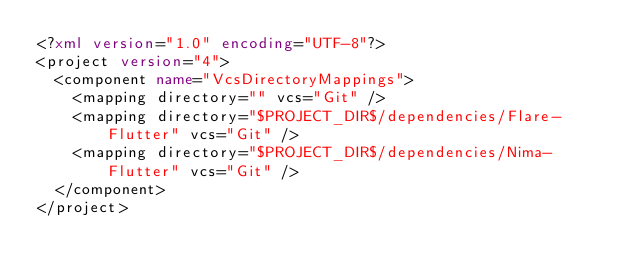<code> <loc_0><loc_0><loc_500><loc_500><_XML_><?xml version="1.0" encoding="UTF-8"?>
<project version="4">
  <component name="VcsDirectoryMappings">
    <mapping directory="" vcs="Git" />
    <mapping directory="$PROJECT_DIR$/dependencies/Flare-Flutter" vcs="Git" />
    <mapping directory="$PROJECT_DIR$/dependencies/Nima-Flutter" vcs="Git" />
  </component>
</project></code> 